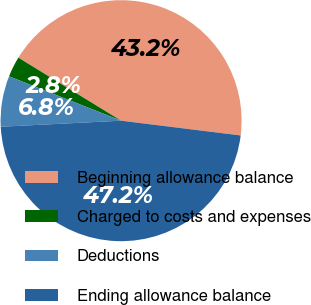<chart> <loc_0><loc_0><loc_500><loc_500><pie_chart><fcel>Beginning allowance balance<fcel>Charged to costs and expenses<fcel>Deductions<fcel>Ending allowance balance<nl><fcel>43.2%<fcel>2.76%<fcel>6.8%<fcel>47.24%<nl></chart> 